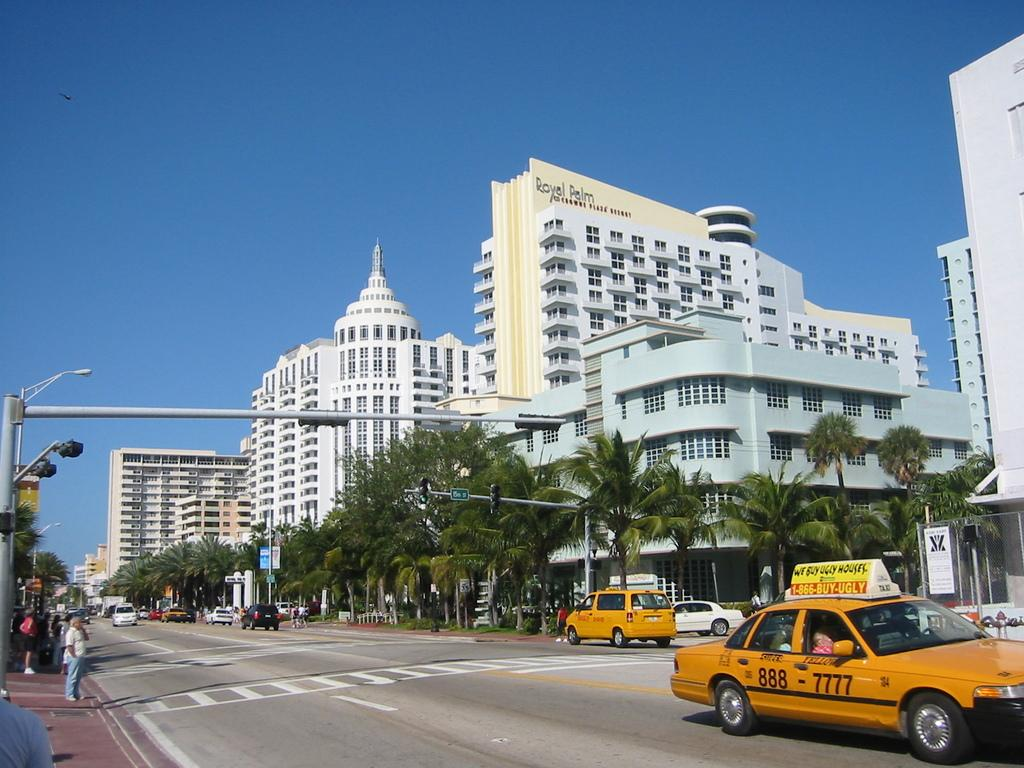<image>
Relay a brief, clear account of the picture shown. A street with a taxi in front of a hotel named Royal Palm. 